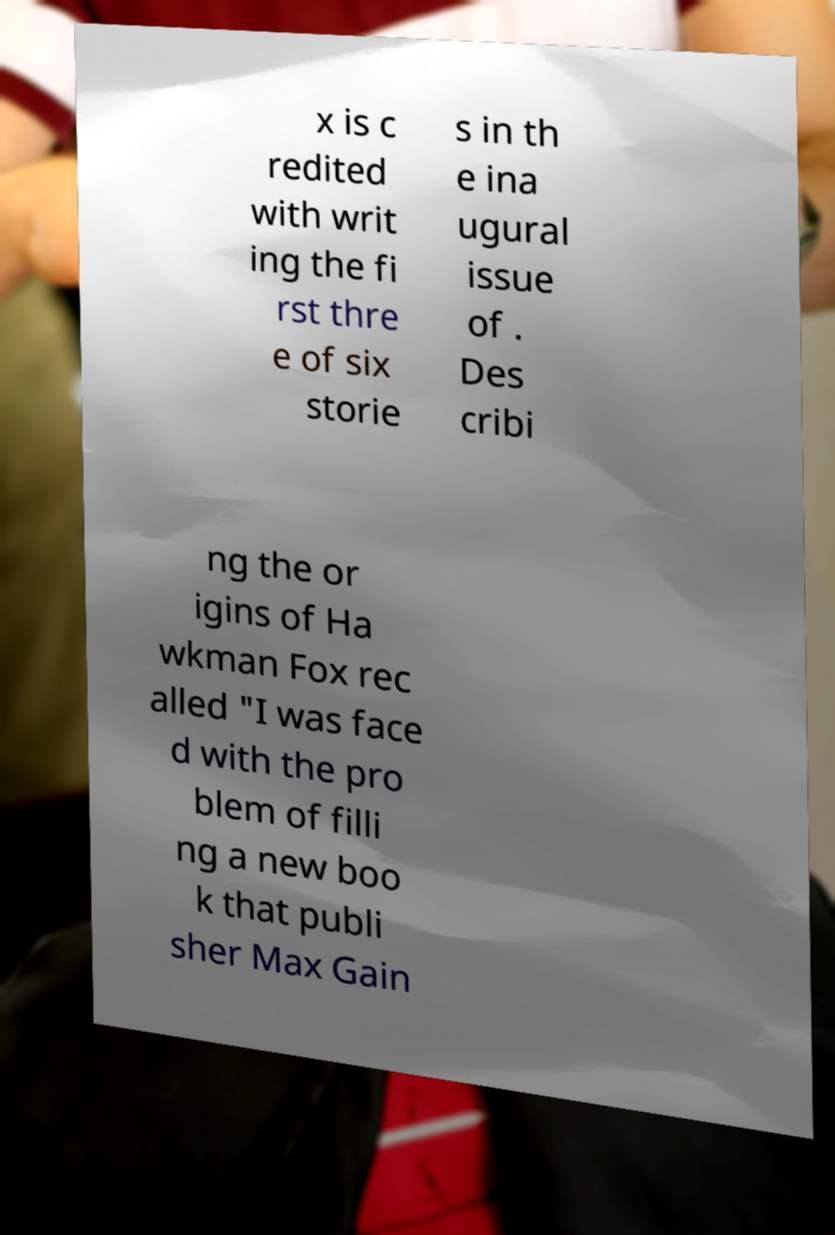What messages or text are displayed in this image? I need them in a readable, typed format. x is c redited with writ ing the fi rst thre e of six storie s in th e ina ugural issue of . Des cribi ng the or igins of Ha wkman Fox rec alled "I was face d with the pro blem of filli ng a new boo k that publi sher Max Gain 